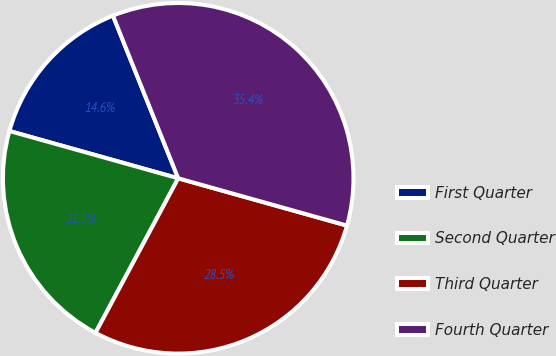Convert chart. <chart><loc_0><loc_0><loc_500><loc_500><pie_chart><fcel>First Quarter<fcel>Second Quarter<fcel>Third Quarter<fcel>Fourth Quarter<nl><fcel>14.58%<fcel>21.53%<fcel>28.47%<fcel>35.42%<nl></chart> 